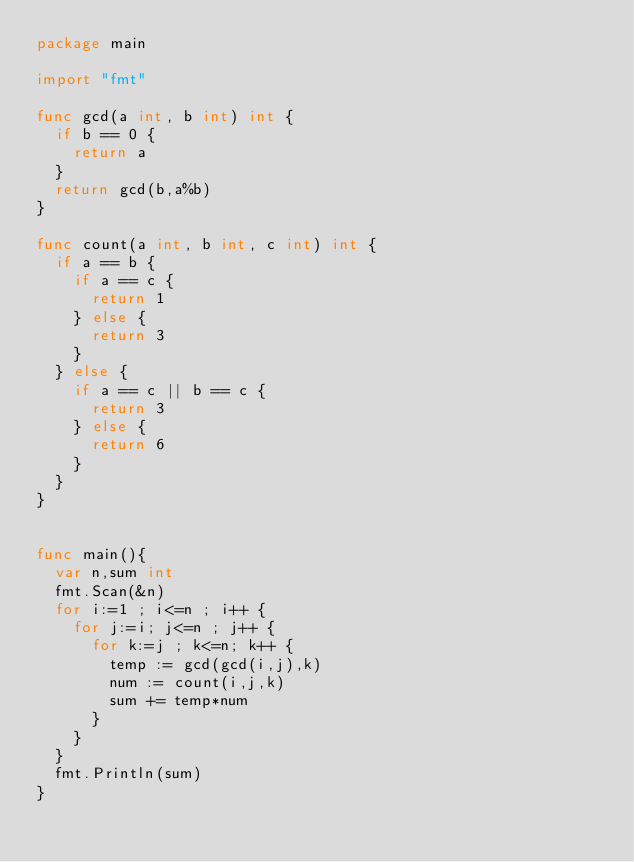<code> <loc_0><loc_0><loc_500><loc_500><_Go_>package main

import "fmt"

func gcd(a int, b int) int {
	if b == 0 {
		return a
	}
	return gcd(b,a%b)
}

func count(a int, b int, c int) int {
	if a == b {
		if a == c {
			return 1
		} else {
			return 3
		}
	} else {
		if a == c || b == c {
			return 3
		} else {
			return 6
		}
	}
}


func main(){
	var n,sum int
	fmt.Scan(&n)
	for i:=1 ; i<=n ; i++ {
		for j:=i; j<=n ; j++ {
			for k:=j ; k<=n; k++ {
				temp := gcd(gcd(i,j),k)
				num := count(i,j,k)
				sum += temp*num
			}
		}
	}
	fmt.Println(sum)
}
</code> 